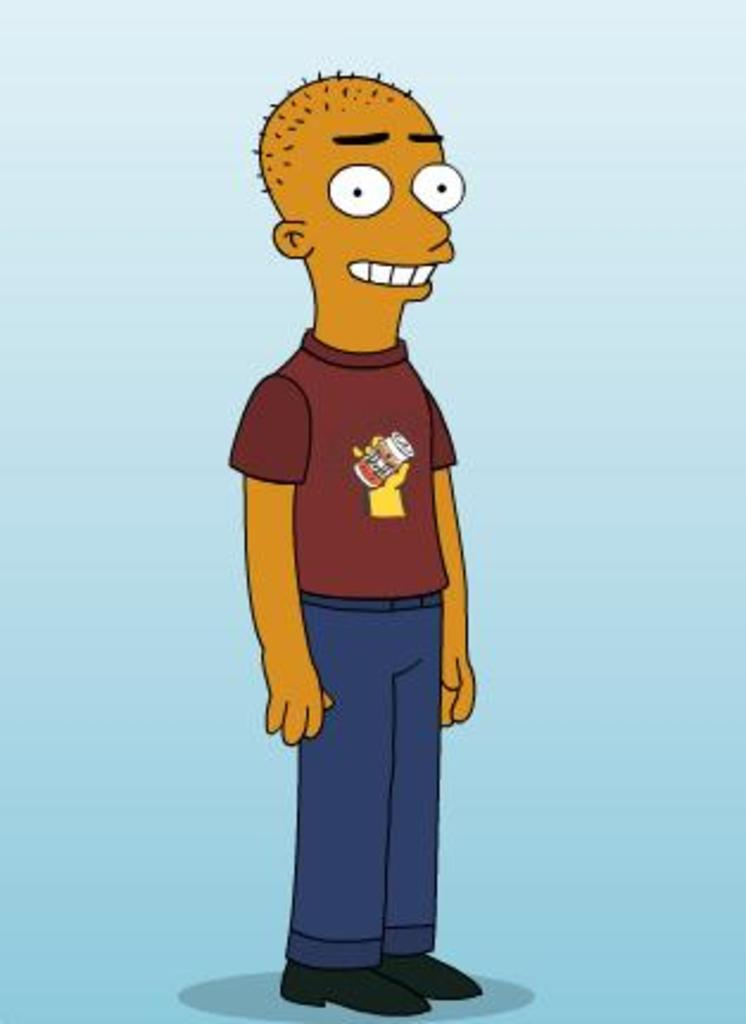What type of character is in the image? There is a cartoon man in the image. What is the cartoon man doing in the image? The cartoon man is standing. What colors are used in the background of the image? The background of the image is white and sky blue in color. What type of furniture can be seen in the image? There is no furniture present in the image; it features a cartoon man standing against a white and sky blue background. 